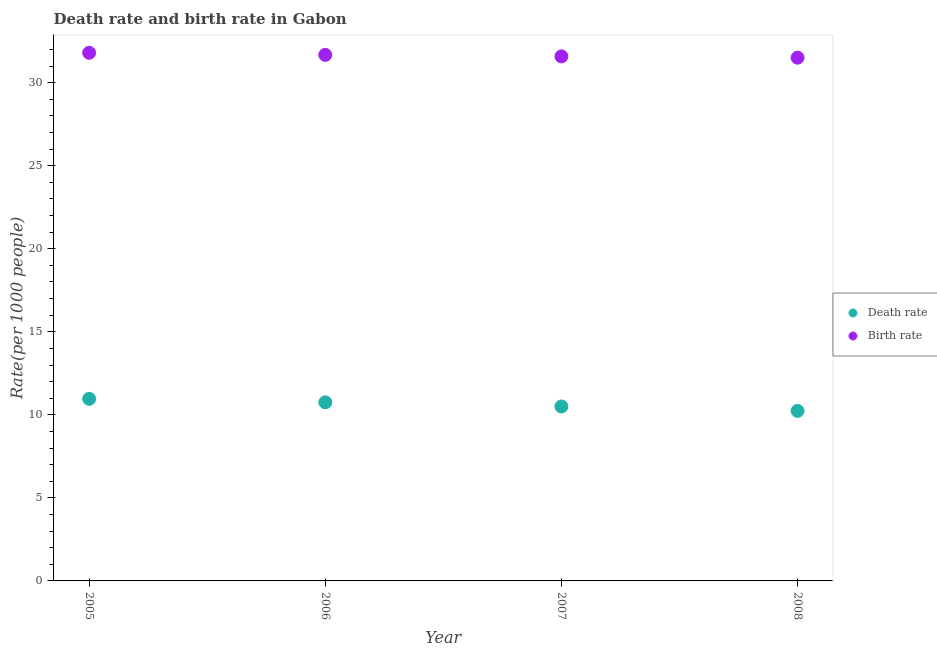How many different coloured dotlines are there?
Your answer should be compact. 2. What is the birth rate in 2007?
Provide a succinct answer. 31.58. Across all years, what is the maximum birth rate?
Offer a very short reply. 31.8. Across all years, what is the minimum birth rate?
Your answer should be compact. 31.5. In which year was the birth rate minimum?
Your answer should be compact. 2008. What is the total birth rate in the graph?
Ensure brevity in your answer.  126.56. What is the difference between the birth rate in 2006 and that in 2007?
Offer a terse response. 0.09. What is the difference between the death rate in 2007 and the birth rate in 2006?
Give a very brief answer. -21.17. What is the average birth rate per year?
Your answer should be very brief. 31.64. In the year 2008, what is the difference between the death rate and birth rate?
Provide a short and direct response. -21.27. In how many years, is the death rate greater than 4?
Make the answer very short. 4. What is the ratio of the death rate in 2006 to that in 2007?
Offer a very short reply. 1.02. Is the death rate in 2007 less than that in 2008?
Make the answer very short. No. What is the difference between the highest and the second highest death rate?
Provide a succinct answer. 0.21. What is the difference between the highest and the lowest death rate?
Ensure brevity in your answer.  0.73. Is the sum of the death rate in 2005 and 2006 greater than the maximum birth rate across all years?
Ensure brevity in your answer.  No. Is the death rate strictly less than the birth rate over the years?
Keep it short and to the point. Yes. How many dotlines are there?
Provide a succinct answer. 2. What is the difference between two consecutive major ticks on the Y-axis?
Your response must be concise. 5. Does the graph contain grids?
Your answer should be compact. No. Where does the legend appear in the graph?
Provide a short and direct response. Center right. What is the title of the graph?
Ensure brevity in your answer.  Death rate and birth rate in Gabon. Does "Official creditors" appear as one of the legend labels in the graph?
Ensure brevity in your answer.  No. What is the label or title of the Y-axis?
Your answer should be compact. Rate(per 1000 people). What is the Rate(per 1000 people) of Death rate in 2005?
Provide a succinct answer. 10.96. What is the Rate(per 1000 people) in Birth rate in 2005?
Keep it short and to the point. 31.8. What is the Rate(per 1000 people) of Death rate in 2006?
Offer a terse response. 10.75. What is the Rate(per 1000 people) in Birth rate in 2006?
Give a very brief answer. 31.67. What is the Rate(per 1000 people) in Death rate in 2007?
Provide a short and direct response. 10.5. What is the Rate(per 1000 people) of Birth rate in 2007?
Provide a short and direct response. 31.58. What is the Rate(per 1000 people) of Death rate in 2008?
Provide a short and direct response. 10.24. What is the Rate(per 1000 people) in Birth rate in 2008?
Your answer should be very brief. 31.5. Across all years, what is the maximum Rate(per 1000 people) of Death rate?
Give a very brief answer. 10.96. Across all years, what is the maximum Rate(per 1000 people) in Birth rate?
Give a very brief answer. 31.8. Across all years, what is the minimum Rate(per 1000 people) in Death rate?
Make the answer very short. 10.24. Across all years, what is the minimum Rate(per 1000 people) of Birth rate?
Ensure brevity in your answer.  31.5. What is the total Rate(per 1000 people) in Death rate in the graph?
Keep it short and to the point. 42.45. What is the total Rate(per 1000 people) in Birth rate in the graph?
Provide a short and direct response. 126.56. What is the difference between the Rate(per 1000 people) in Death rate in 2005 and that in 2006?
Provide a short and direct response. 0.21. What is the difference between the Rate(per 1000 people) of Birth rate in 2005 and that in 2006?
Provide a succinct answer. 0.12. What is the difference between the Rate(per 1000 people) of Death rate in 2005 and that in 2007?
Your answer should be compact. 0.46. What is the difference between the Rate(per 1000 people) in Birth rate in 2005 and that in 2007?
Provide a succinct answer. 0.22. What is the difference between the Rate(per 1000 people) in Death rate in 2005 and that in 2008?
Ensure brevity in your answer.  0.73. What is the difference between the Rate(per 1000 people) in Birth rate in 2005 and that in 2008?
Your response must be concise. 0.29. What is the difference between the Rate(per 1000 people) in Death rate in 2006 and that in 2007?
Provide a succinct answer. 0.25. What is the difference between the Rate(per 1000 people) in Birth rate in 2006 and that in 2007?
Your answer should be very brief. 0.09. What is the difference between the Rate(per 1000 people) in Death rate in 2006 and that in 2008?
Provide a succinct answer. 0.52. What is the difference between the Rate(per 1000 people) in Birth rate in 2006 and that in 2008?
Your answer should be very brief. 0.17. What is the difference between the Rate(per 1000 people) in Death rate in 2007 and that in 2008?
Your response must be concise. 0.27. What is the difference between the Rate(per 1000 people) of Birth rate in 2007 and that in 2008?
Offer a very short reply. 0.08. What is the difference between the Rate(per 1000 people) in Death rate in 2005 and the Rate(per 1000 people) in Birth rate in 2006?
Make the answer very short. -20.71. What is the difference between the Rate(per 1000 people) in Death rate in 2005 and the Rate(per 1000 people) in Birth rate in 2007?
Your response must be concise. -20.62. What is the difference between the Rate(per 1000 people) of Death rate in 2005 and the Rate(per 1000 people) of Birth rate in 2008?
Your response must be concise. -20.54. What is the difference between the Rate(per 1000 people) in Death rate in 2006 and the Rate(per 1000 people) in Birth rate in 2007?
Offer a terse response. -20.83. What is the difference between the Rate(per 1000 people) in Death rate in 2006 and the Rate(per 1000 people) in Birth rate in 2008?
Your answer should be very brief. -20.75. What is the difference between the Rate(per 1000 people) of Death rate in 2007 and the Rate(per 1000 people) of Birth rate in 2008?
Your answer should be compact. -21. What is the average Rate(per 1000 people) of Death rate per year?
Offer a terse response. 10.61. What is the average Rate(per 1000 people) in Birth rate per year?
Provide a short and direct response. 31.64. In the year 2005, what is the difference between the Rate(per 1000 people) of Death rate and Rate(per 1000 people) of Birth rate?
Ensure brevity in your answer.  -20.84. In the year 2006, what is the difference between the Rate(per 1000 people) of Death rate and Rate(per 1000 people) of Birth rate?
Keep it short and to the point. -20.92. In the year 2007, what is the difference between the Rate(per 1000 people) of Death rate and Rate(per 1000 people) of Birth rate?
Your answer should be compact. -21.08. In the year 2008, what is the difference between the Rate(per 1000 people) in Death rate and Rate(per 1000 people) in Birth rate?
Provide a short and direct response. -21.27. What is the ratio of the Rate(per 1000 people) in Death rate in 2005 to that in 2006?
Give a very brief answer. 1.02. What is the ratio of the Rate(per 1000 people) of Birth rate in 2005 to that in 2006?
Your answer should be compact. 1. What is the ratio of the Rate(per 1000 people) in Death rate in 2005 to that in 2007?
Provide a short and direct response. 1.04. What is the ratio of the Rate(per 1000 people) of Birth rate in 2005 to that in 2007?
Ensure brevity in your answer.  1.01. What is the ratio of the Rate(per 1000 people) in Death rate in 2005 to that in 2008?
Your answer should be compact. 1.07. What is the ratio of the Rate(per 1000 people) of Birth rate in 2005 to that in 2008?
Give a very brief answer. 1.01. What is the ratio of the Rate(per 1000 people) in Death rate in 2006 to that in 2007?
Provide a succinct answer. 1.02. What is the ratio of the Rate(per 1000 people) in Death rate in 2006 to that in 2008?
Offer a terse response. 1.05. What is the ratio of the Rate(per 1000 people) of Birth rate in 2006 to that in 2008?
Keep it short and to the point. 1.01. What is the ratio of the Rate(per 1000 people) of Death rate in 2007 to that in 2008?
Give a very brief answer. 1.03. What is the ratio of the Rate(per 1000 people) of Birth rate in 2007 to that in 2008?
Your answer should be compact. 1. What is the difference between the highest and the second highest Rate(per 1000 people) in Death rate?
Your answer should be compact. 0.21. What is the difference between the highest and the lowest Rate(per 1000 people) of Death rate?
Give a very brief answer. 0.73. What is the difference between the highest and the lowest Rate(per 1000 people) in Birth rate?
Your answer should be very brief. 0.29. 